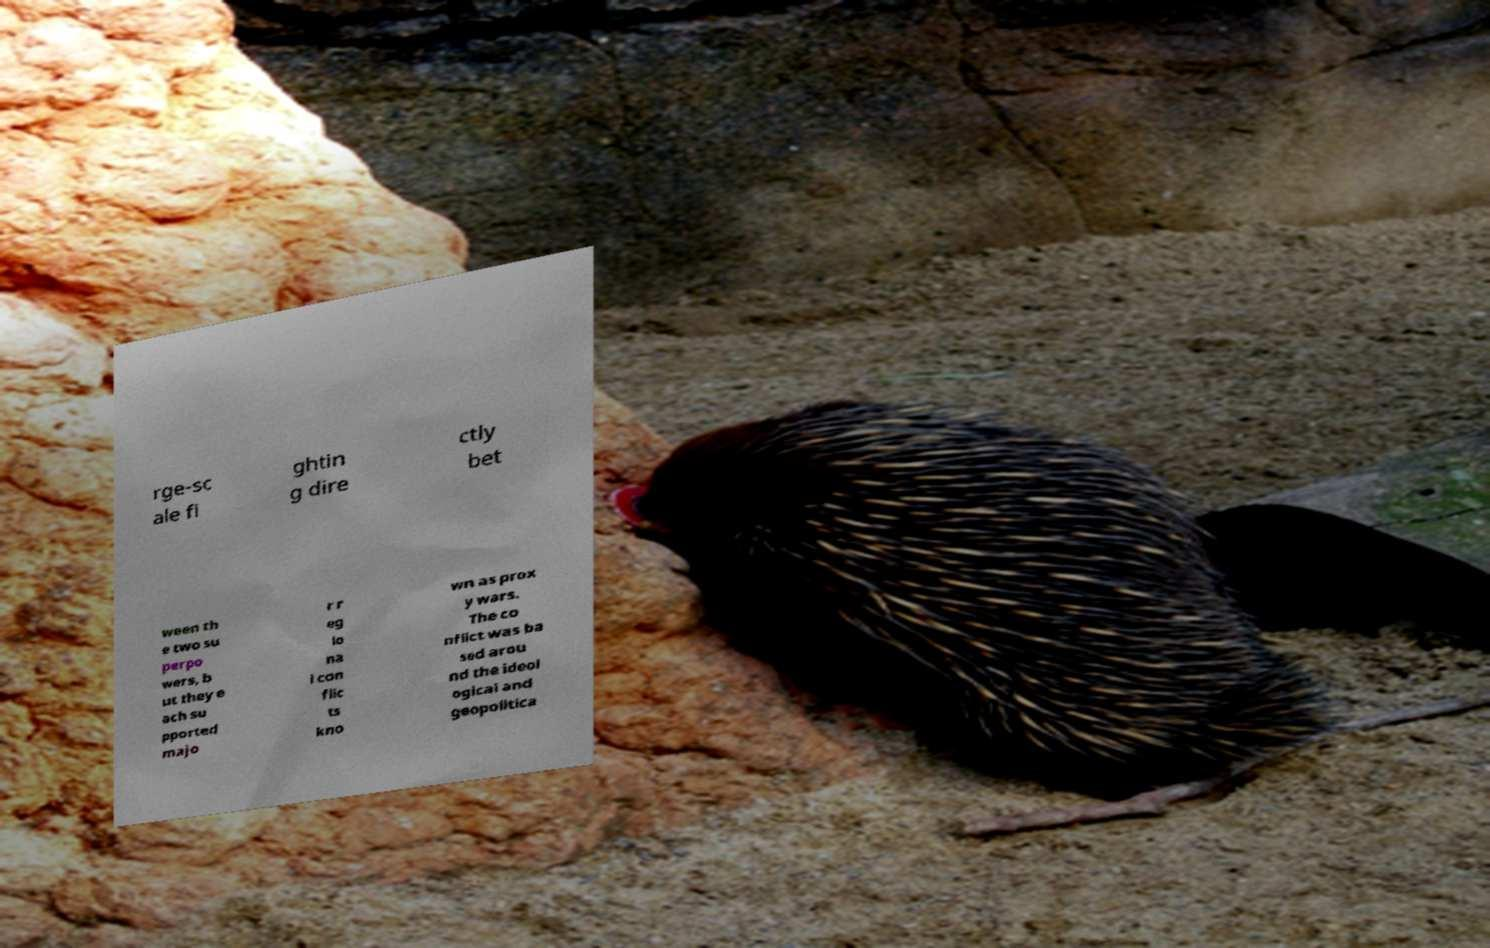Can you read and provide the text displayed in the image?This photo seems to have some interesting text. Can you extract and type it out for me? rge-sc ale fi ghtin g dire ctly bet ween th e two su perpo wers, b ut they e ach su pported majo r r eg io na l con flic ts kno wn as prox y wars. The co nflict was ba sed arou nd the ideol ogical and geopolitica 